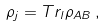<formula> <loc_0><loc_0><loc_500><loc_500>\rho _ { j } = T r _ { l } \rho _ { A B } \, ,</formula> 